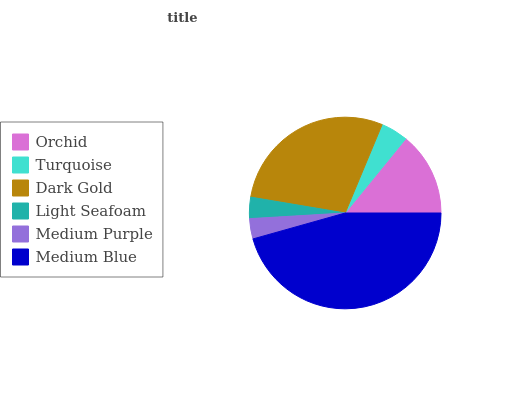Is Medium Purple the minimum?
Answer yes or no. Yes. Is Medium Blue the maximum?
Answer yes or no. Yes. Is Turquoise the minimum?
Answer yes or no. No. Is Turquoise the maximum?
Answer yes or no. No. Is Orchid greater than Turquoise?
Answer yes or no. Yes. Is Turquoise less than Orchid?
Answer yes or no. Yes. Is Turquoise greater than Orchid?
Answer yes or no. No. Is Orchid less than Turquoise?
Answer yes or no. No. Is Orchid the high median?
Answer yes or no. Yes. Is Turquoise the low median?
Answer yes or no. Yes. Is Dark Gold the high median?
Answer yes or no. No. Is Light Seafoam the low median?
Answer yes or no. No. 